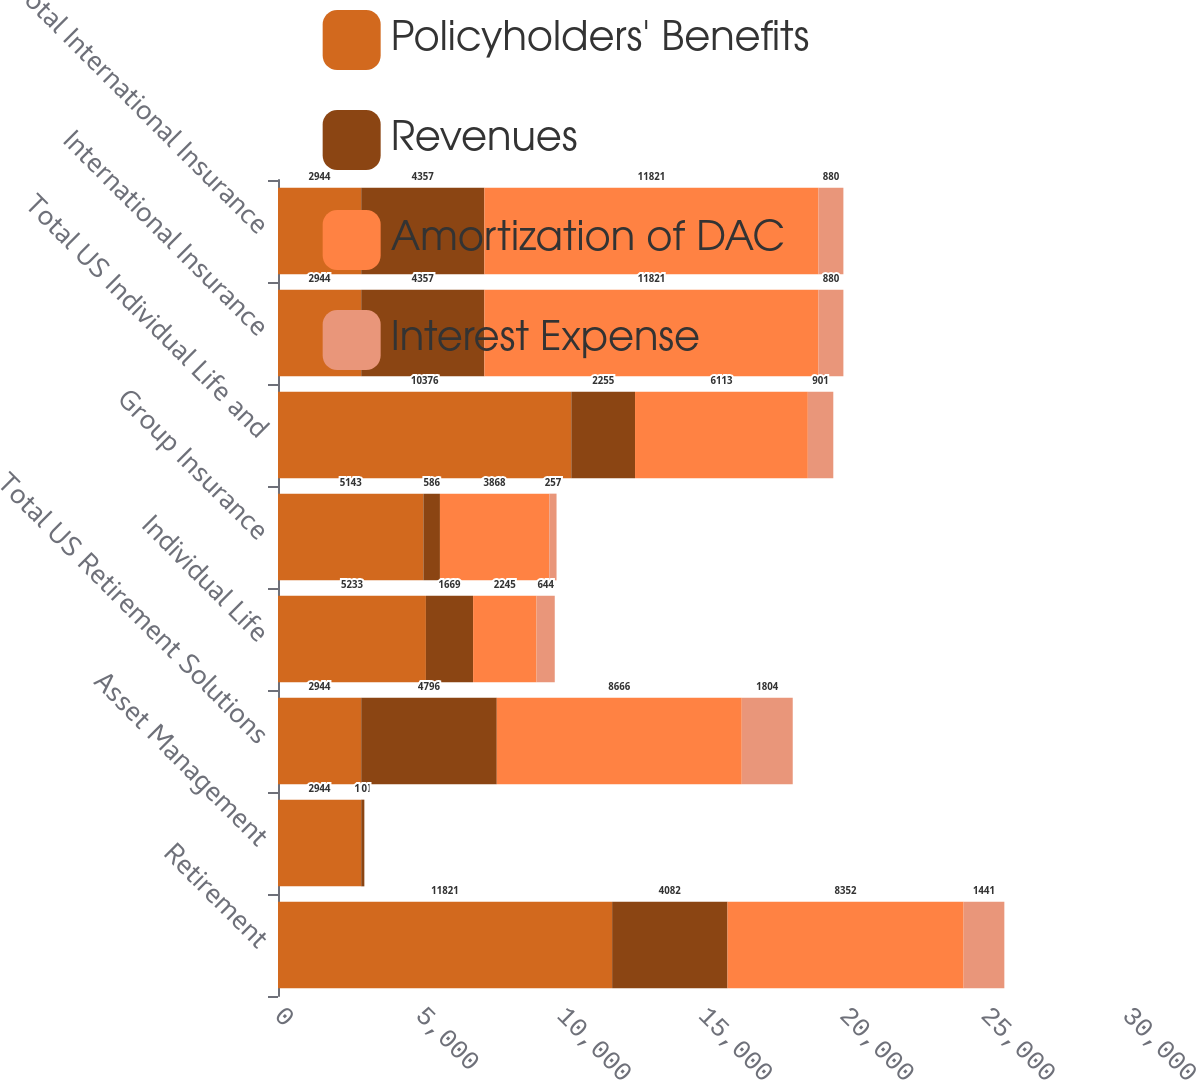Convert chart to OTSL. <chart><loc_0><loc_0><loc_500><loc_500><stacked_bar_chart><ecel><fcel>Retirement<fcel>Asset Management<fcel>Total US Retirement Solutions<fcel>Individual Life<fcel>Group Insurance<fcel>Total US Individual Life and<fcel>International Insurance<fcel>Total International Insurance<nl><fcel>Policyholders' Benefits<fcel>11821<fcel>2944<fcel>2944<fcel>5233<fcel>5143<fcel>10376<fcel>2944<fcel>2944<nl><fcel>Revenues<fcel>4082<fcel>111<fcel>4796<fcel>1669<fcel>586<fcel>2255<fcel>4357<fcel>4357<nl><fcel>Amortization of DAC<fcel>8352<fcel>0<fcel>8666<fcel>2245<fcel>3868<fcel>6113<fcel>11821<fcel>11821<nl><fcel>Interest Expense<fcel>1441<fcel>0<fcel>1804<fcel>644<fcel>257<fcel>901<fcel>880<fcel>880<nl></chart> 